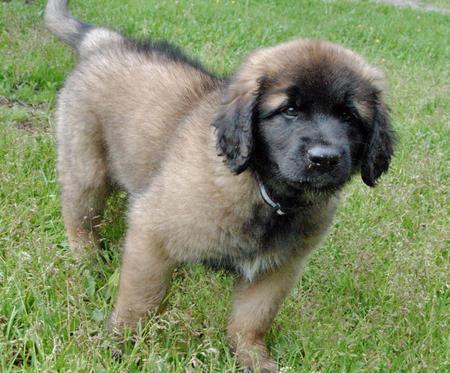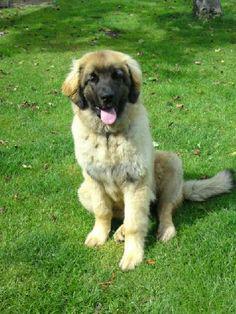The first image is the image on the left, the second image is the image on the right. Considering the images on both sides, is "One image features two dogs, and adult and a puppy, in an outdoor setting." valid? Answer yes or no. No. 